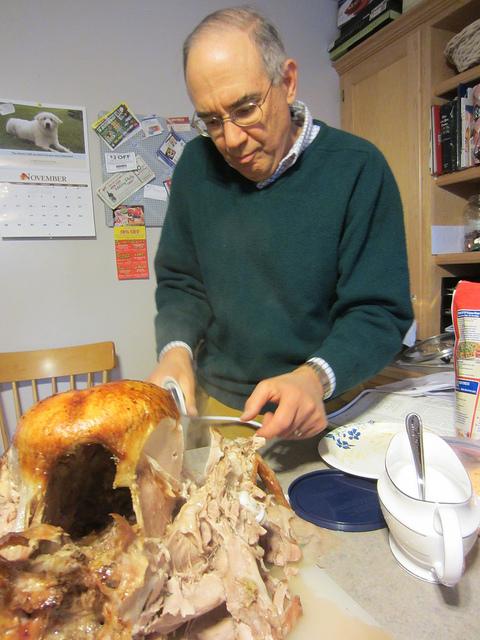What holiday is that meat usually served on?
Be succinct. Thanksgiving. What room is this?
Write a very short answer. Kitchen. Has the man recently shaved?
Short answer required. Yes. Did the meat come with the bone in?
Write a very short answer. Yes. Is this man dining at home?
Quick response, please. Yes. 